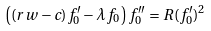Convert formula to latex. <formula><loc_0><loc_0><loc_500><loc_500>\left ( ( r w - c ) f _ { 0 } ^ { \prime } - \lambda f _ { 0 } \right ) f _ { 0 } ^ { \prime \prime } = R ( f _ { 0 } ^ { \prime } ) ^ { 2 }</formula> 